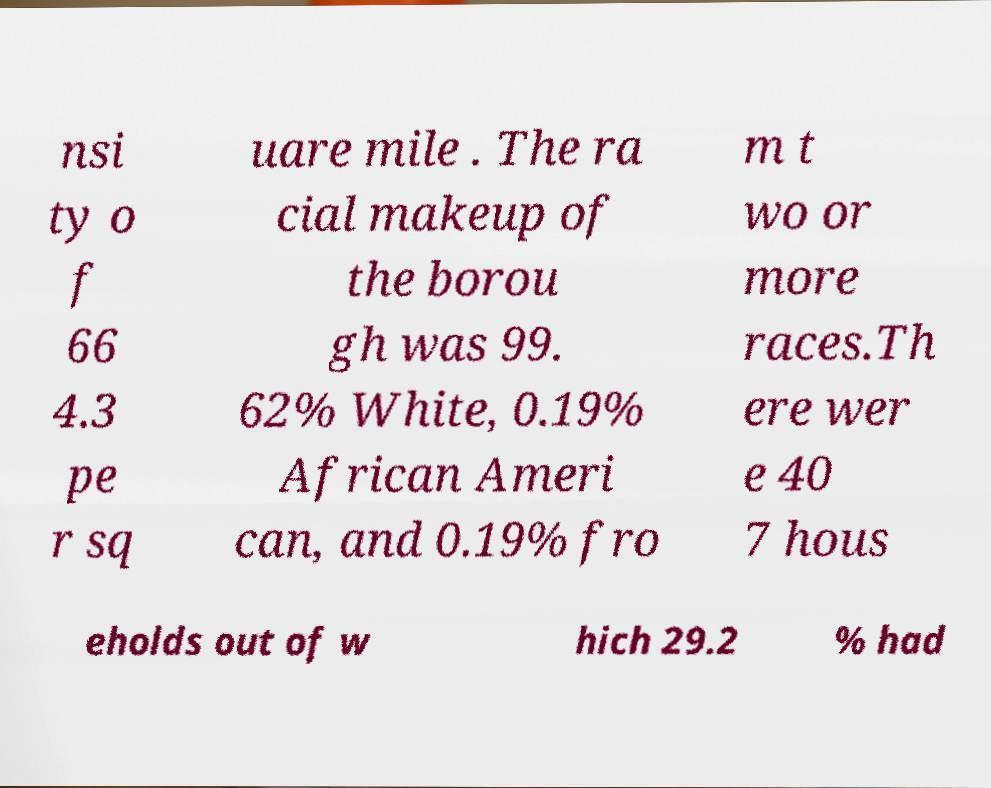Please read and relay the text visible in this image. What does it say? nsi ty o f 66 4.3 pe r sq uare mile . The ra cial makeup of the borou gh was 99. 62% White, 0.19% African Ameri can, and 0.19% fro m t wo or more races.Th ere wer e 40 7 hous eholds out of w hich 29.2 % had 